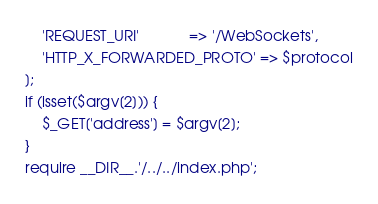<code> <loc_0><loc_0><loc_500><loc_500><_PHP_>	'REQUEST_URI'            => '/WebSockets',
	'HTTP_X_FORWARDED_PROTO' => $protocol
];
if (isset($argv[2])) {
	$_GET['address'] = $argv[2];
}
require __DIR__.'/../../index.php';
</code> 